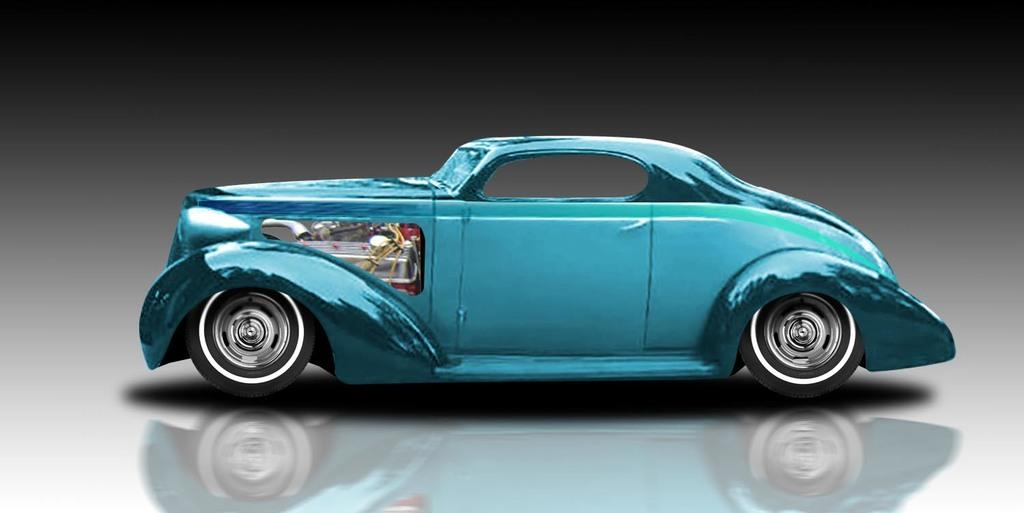What type of toy is in the image? There is a blue toy car in the image. What is the toy car placed on? The toy car is on an object. What type of division is taking place in the image? There is no division taking place in the image; it features a blue toy car on an object. Can you see a hose in the image? There is no hose present in the image. 